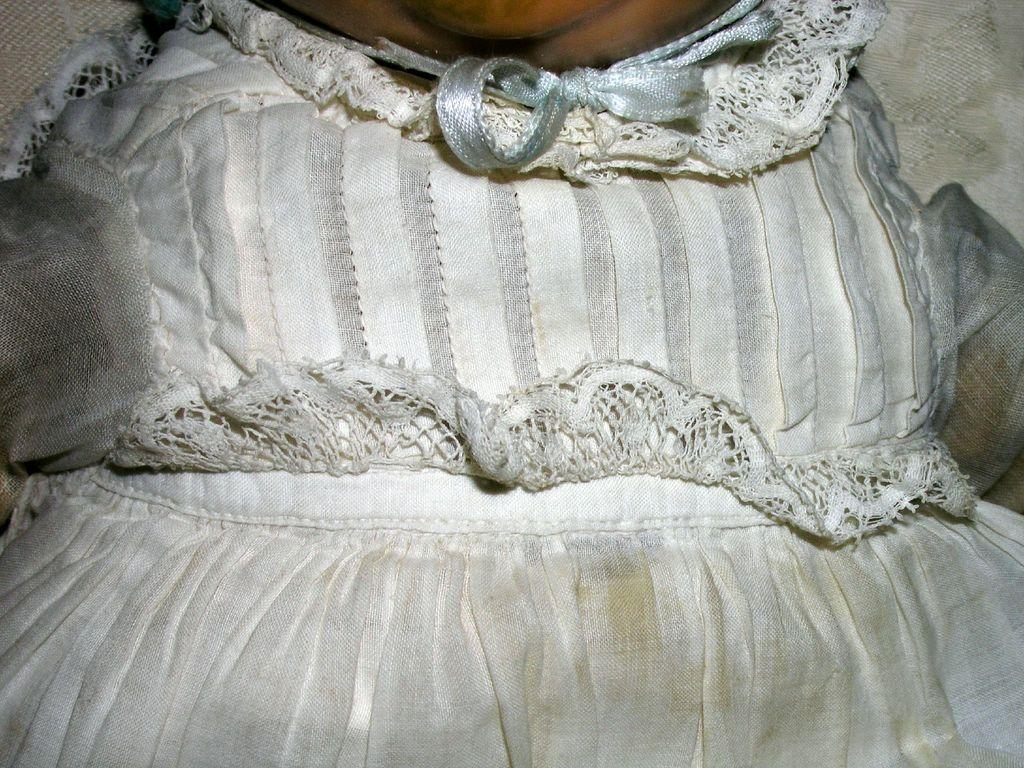What color is the dress in the image? The dress in the image is white. Can you describe any other elements in the image besides the dress? Yes, there is a cloth in the background of the image. What type of bone can be seen in the image? There is no bone present in the image. What channel is the image from? The image is not from a channel; it is a still image. 